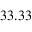<formula> <loc_0><loc_0><loc_500><loc_500>3 3 . 3 3 \</formula> 